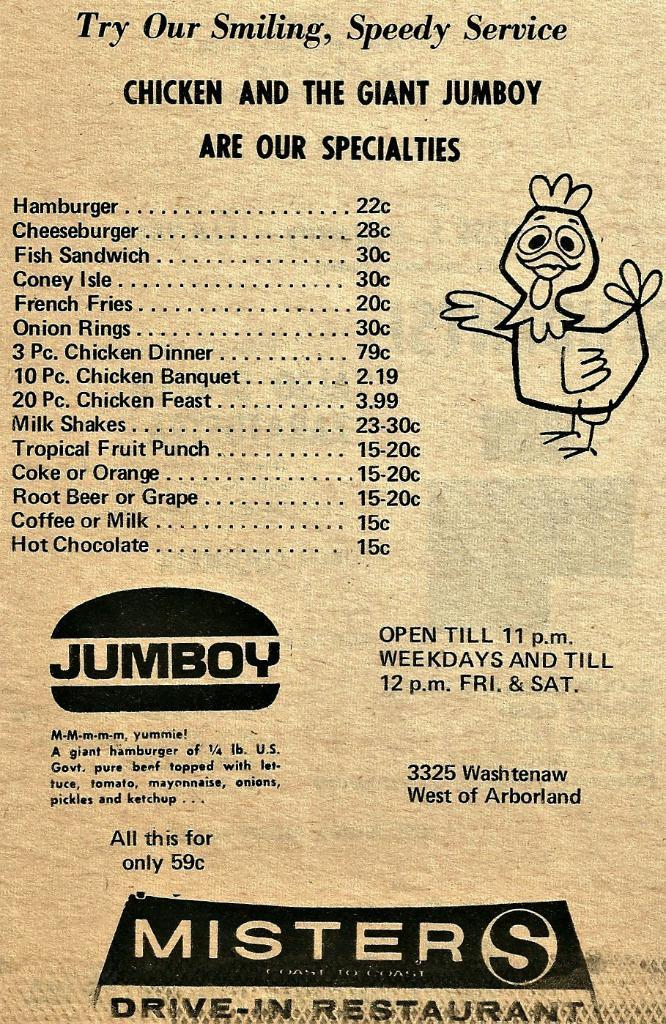Provide a one-sentence caption for the provided image. A menu for Misters Drive-In Restaruant with a chicken on it. 